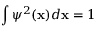Convert formula to latex. <formula><loc_0><loc_0><loc_500><loc_500>\int \psi ^ { 2 } ( x ) d x = 1</formula> 